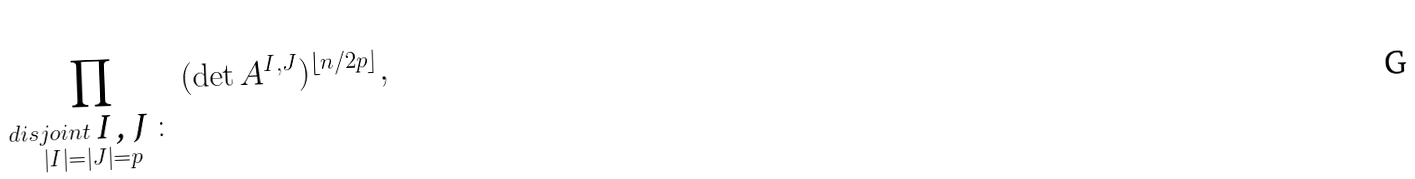Convert formula to latex. <formula><loc_0><loc_0><loc_500><loc_500>\prod _ { \substack { d i s j o i n t $ I , J $ \colon \\ | I | = | J | = p } } \, ( \det A ^ { I , J } ) ^ { \lfloor n / 2 p \rfloor } ,</formula> 